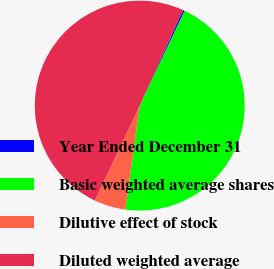Convert chart. <chart><loc_0><loc_0><loc_500><loc_500><pie_chart><fcel>Year Ended December 31<fcel>Basic weighted average shares<fcel>Dilutive effect of stock<fcel>Diluted weighted average<nl><fcel>0.27%<fcel>45.16%<fcel>4.84%<fcel>49.73%<nl></chart> 